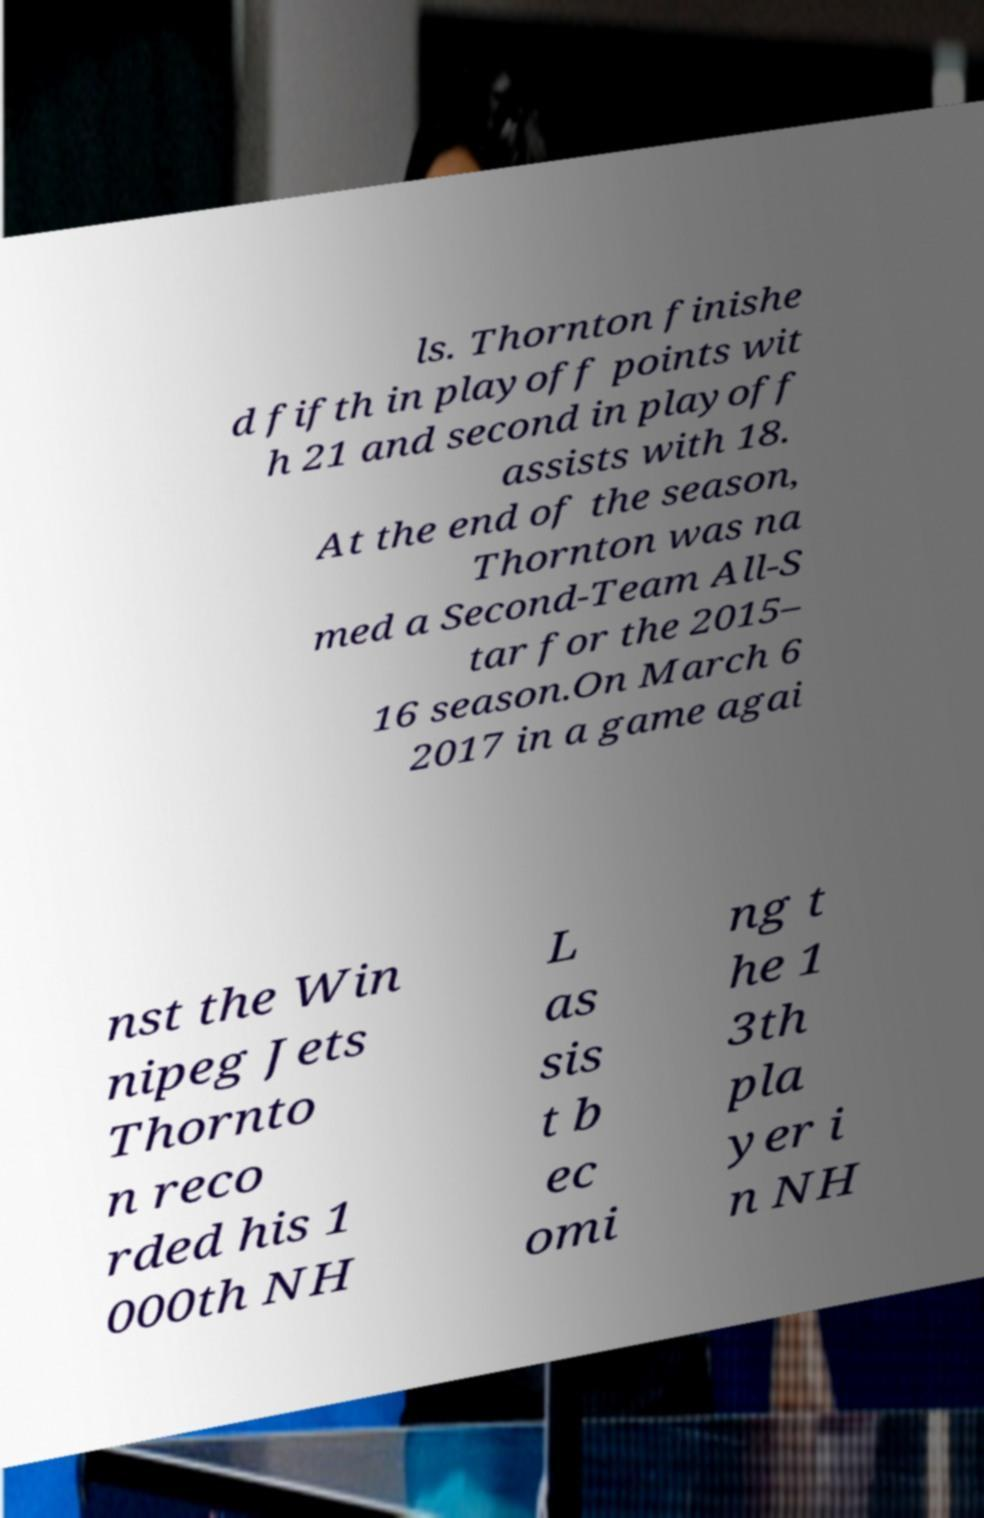Please identify and transcribe the text found in this image. ls. Thornton finishe d fifth in playoff points wit h 21 and second in playoff assists with 18. At the end of the season, Thornton was na med a Second-Team All-S tar for the 2015– 16 season.On March 6 2017 in a game agai nst the Win nipeg Jets Thornto n reco rded his 1 000th NH L as sis t b ec omi ng t he 1 3th pla yer i n NH 